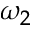Convert formula to latex. <formula><loc_0><loc_0><loc_500><loc_500>\omega _ { 2 }</formula> 